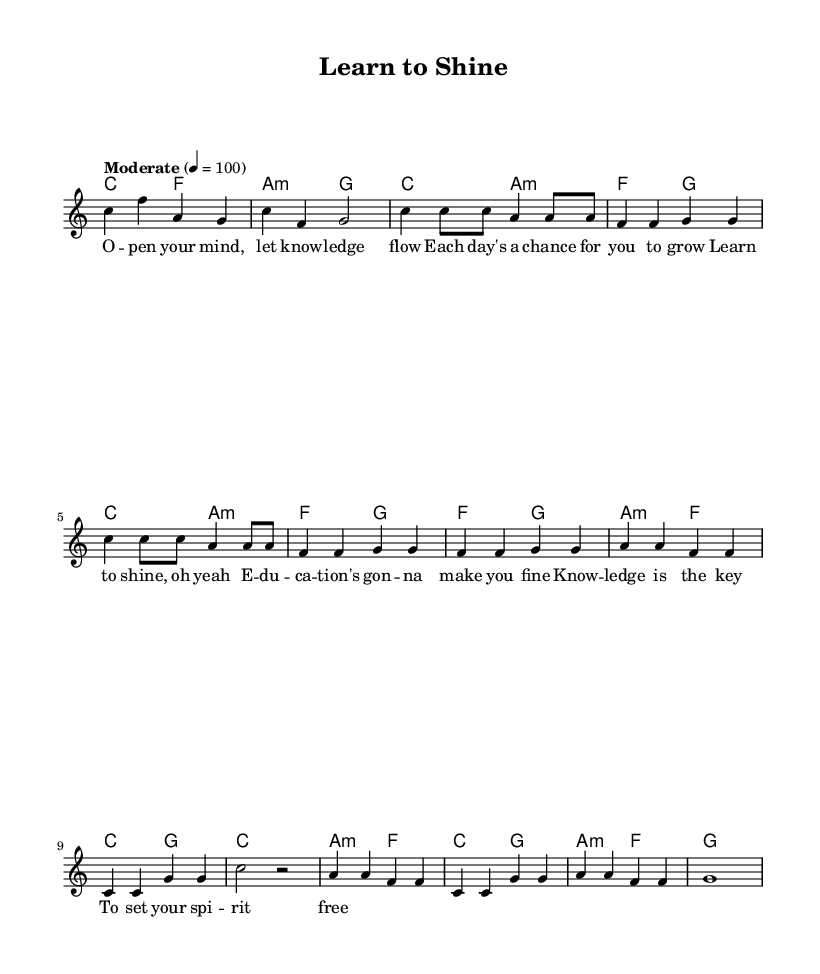What is the key signature of this music? The key signature is C major, which has no sharps or flats.
Answer: C major What is the time signature of this sheet music? The time signature shown at the beginning is 4/4, which indicates four beats per measure.
Answer: 4/4 What tempo marking is indicated in the score? The tempo marking states "Moderate" at a speed of 100 beats per minute, guiding the performance tempo.
Answer: Moderate 100 How many measures are in the chorus section? The chorus is composed of 4 measures, as indicated by the notation layout and structure of the music within the sheet.
Answer: 4 What is the first line of lyrics in the verse? The first line of lyrics in the verse is "Open your mind, let knowledge flow," which starts the theme of education and growth.
Answer: Open your mind, let knowledge flow How many unique chord changes are there in the chorus? In the chorus, there are 3 unique chord changes: F, A minor, and C, which provide harmonic variety to the music.
Answer: 3 What thematic element does the bridge convey in the song? The bridge emphasizes knowledge being the key to personal freedom, reinforcing the song's overall message about education and personal growth.
Answer: Knowledge is the key 